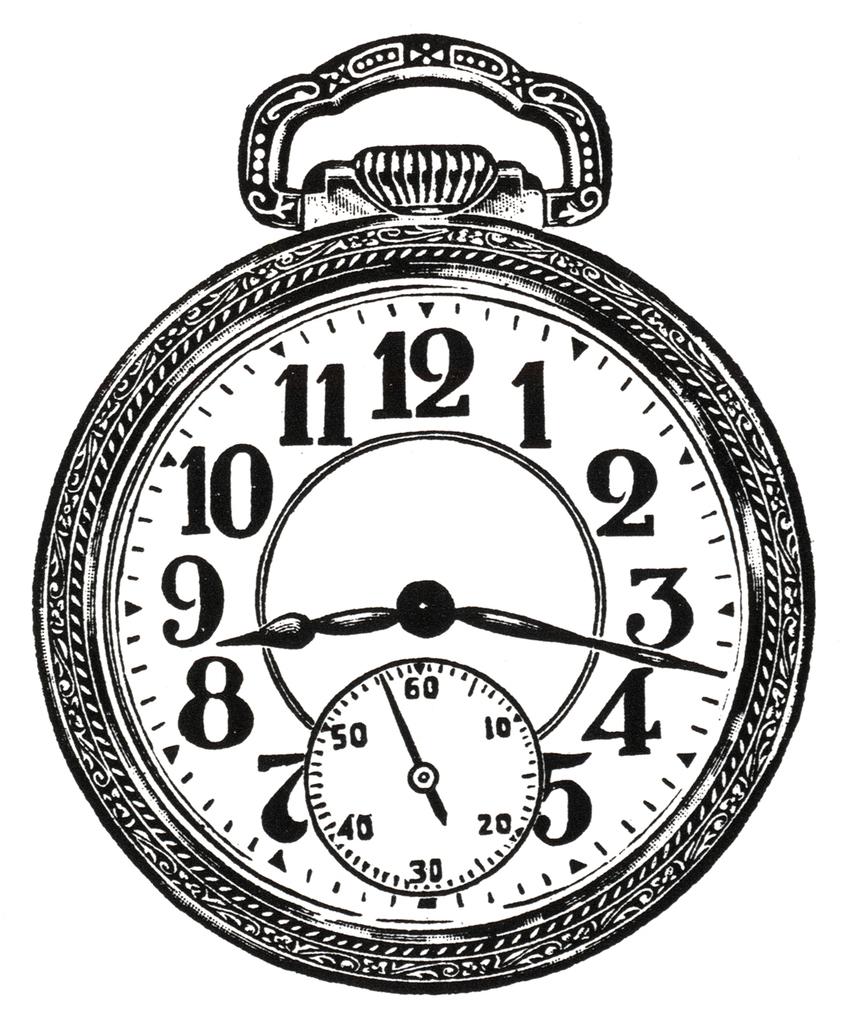What time is it?
Provide a short and direct response. 8:17. What displayed number is the second hand pointing the closest to?
Offer a very short reply. 3. 